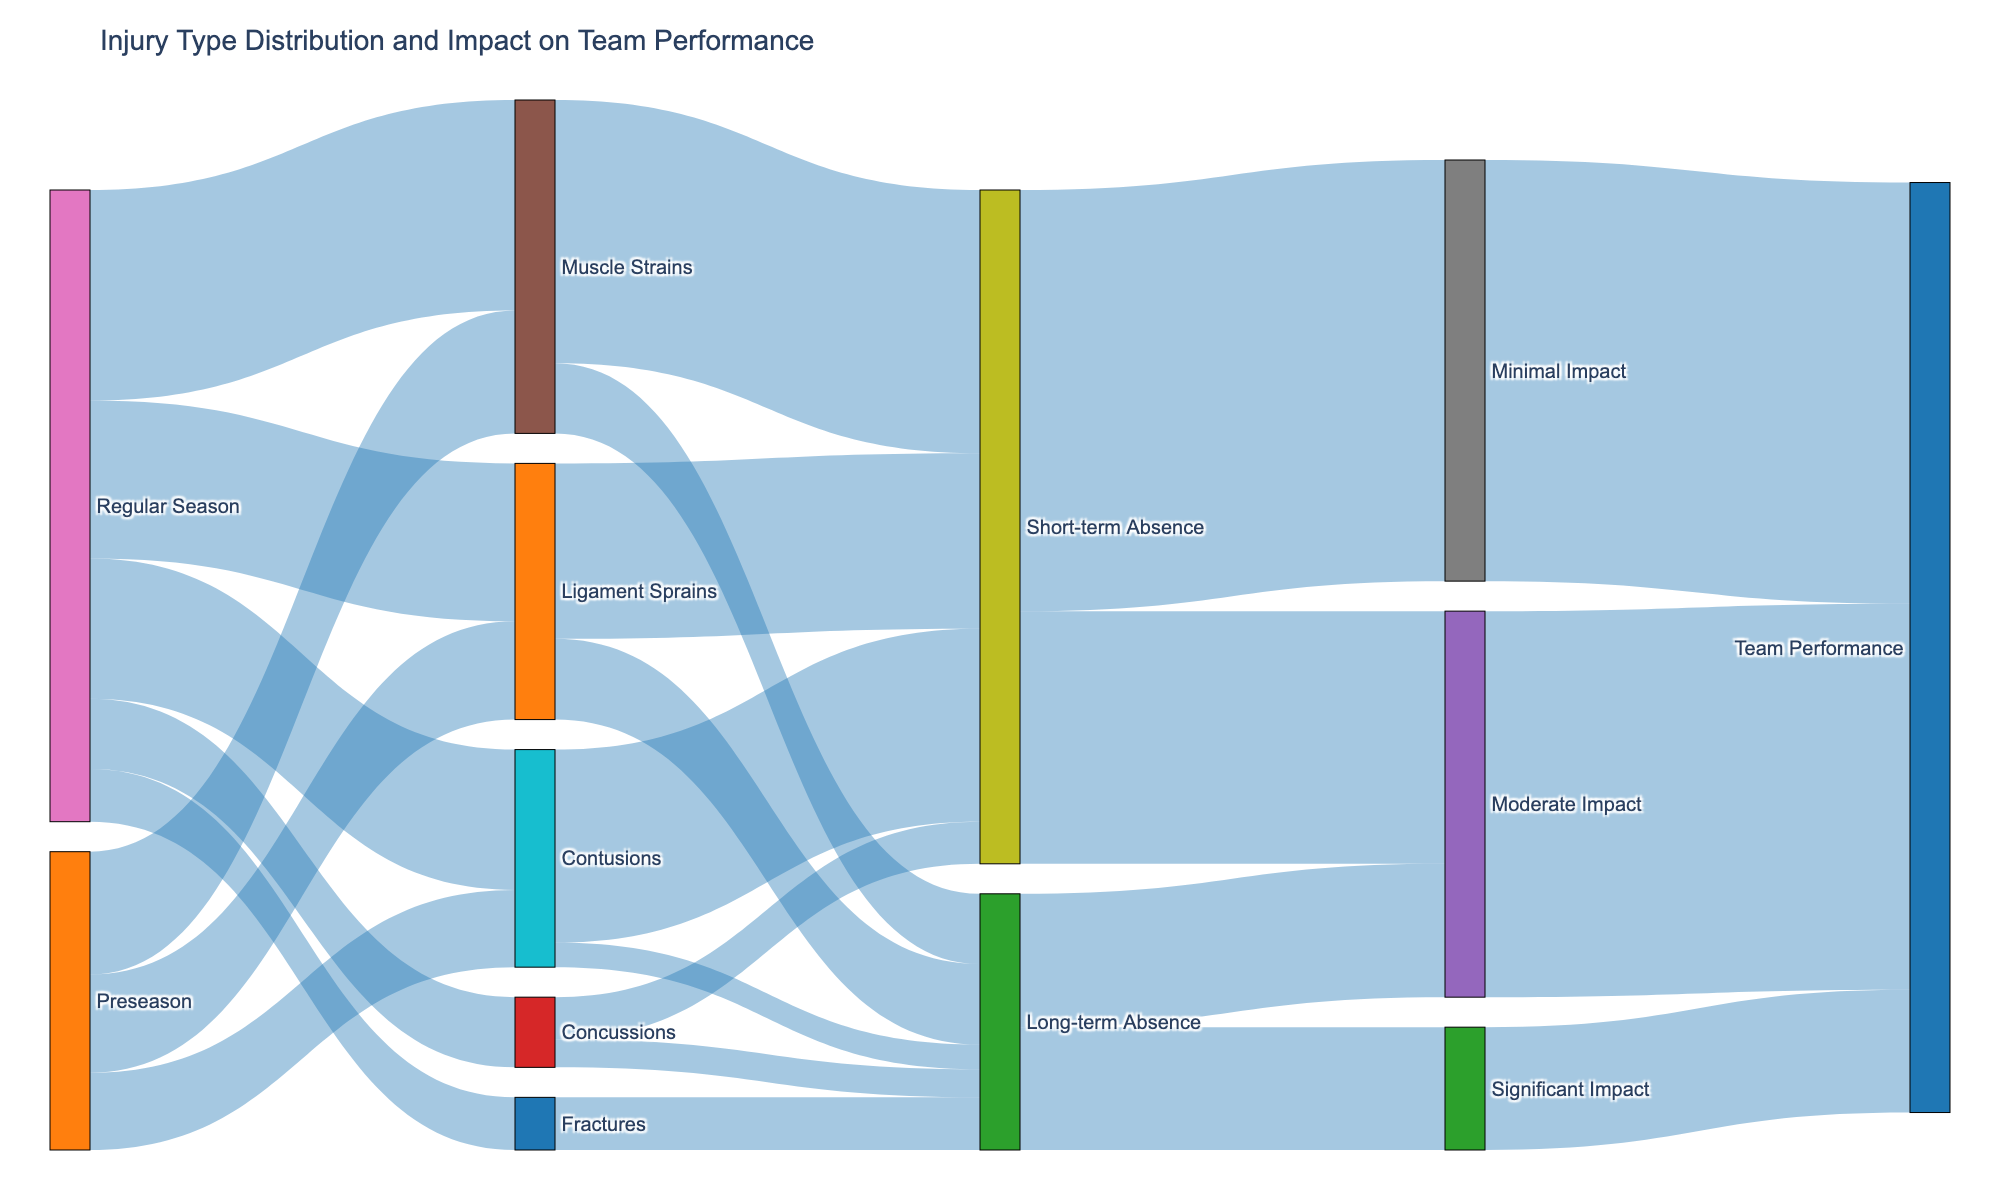what is the title of the figure? The title is located at the top center of the figure and provides an overview of what the diagram is about. In this case, it clearly states the context of the data presented.
Answer: Injury Type Distribution and Impact on Team Performance Which injury type is most common during the regular season? To determine the most common injury type during the regular season, look at the flows originating from "Regular Season" and compare their values.
Answer: Muscle Strains How many players had muscle strains in both the preseason and regular season combined? Add the number of muscle strains from the preseason and regular season flows. According to the data provided, there are 35 muscle strains in the preseason and 60 in the regular season.
Answer: 95 players What type of absence is most commonly caused by contusions? Follow the flow from "Contusions" to see which type of absence it leads to most frequently. The flow with the highest value represents the most common type of absence.
Answer: Short-term Absence Comparing ligament sprains and fractures, which had a greater impact on team performance? Trace the flows from "Ligament Sprains" and "Fractures" through to their respective impact levels, and sum up the values leading to "Team Performance" for each. Ligament sprains result in 50 short-term and 23 long-term absences, impacting minimally and moderately, whereas fractures lead directly to long-term absence, impacting significantly.
Answer: Ligament Sprains How many players experienced short-term absences, and what was the total impact? Count the total flow into "Short-term Absence" by summing the values from different injuries. Then, follow flows out of "Short-term Absence" to see the total impact in terms of minimal and moderate impact.
Answer: 192 players; Total impact: 192 (120 Minimal + 72 Moderate) How does the significant impact compare to the moderate impact in terms of team performance? Compare the number of players leading to "Significant Impact" against those leading to "Moderate Impact." Significant Impact has a flow value of 35, while Moderate Impact has a cumulative flow value of 110.
Answer: Moderate Impact is greater Which type of impact on team performance is most common according to the figure? Follow the final flows into "Team Performance" and compare the values for minimal, moderate, and significant impacts. Identify the one with the highest value.
Answer: Minimal Impact What contribution do concussions make to short and long-term absences? Trace the flows from "Concussions" to "Short-term Absence" and "Long-term Absence", and note the values for each.
Answer: Short-term: 12; Long-term: 8 